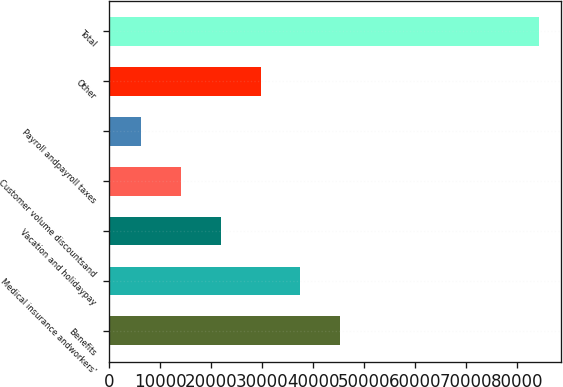<chart> <loc_0><loc_0><loc_500><loc_500><bar_chart><fcel>Benefits<fcel>Medical insurance andworkers'<fcel>Vacation and holidaypay<fcel>Customer volume discountsand<fcel>Payroll andpayroll taxes<fcel>Other<fcel>Total<nl><fcel>45305.5<fcel>37491<fcel>21862<fcel>14047.5<fcel>6233<fcel>29676.5<fcel>84378<nl></chart> 